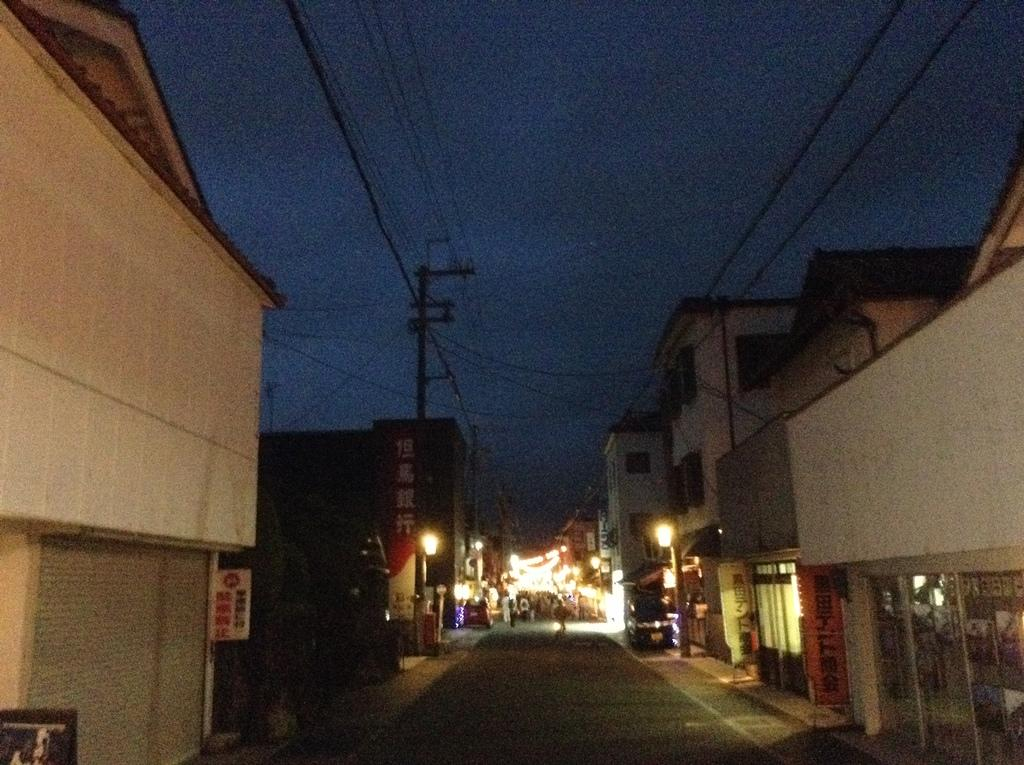What type of structures can be seen in the image? There are buildings in the image. What else can be seen on the buildings or nearby? There are sign boards with text and an utility pole with wires in the image. Can you describe any other objects or features in the image? There are poles and lights visible in the image. What can be seen in the background of the image? The sky is visible in the image. What type of bag is being carried by the hope in the image? There is no hope or bag present in the image. Is there a crook visible in the image? There is no crook present in the image. 